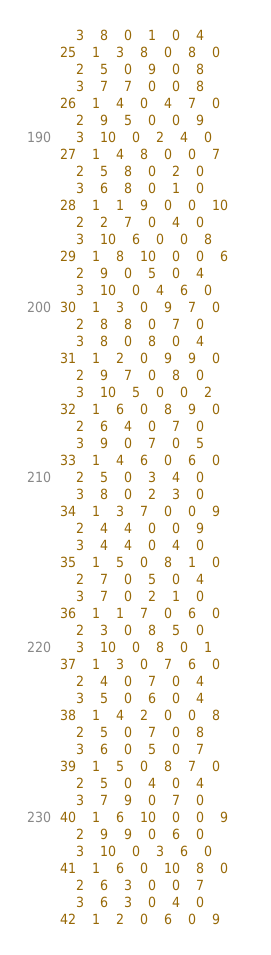Convert code to text. <code><loc_0><loc_0><loc_500><loc_500><_ObjectiveC_>	3	8	0	1	0	4	
25	1	3	8	0	8	0	
	2	5	0	9	0	8	
	3	7	7	0	0	8	
26	1	4	0	4	7	0	
	2	9	5	0	0	9	
	3	10	0	2	4	0	
27	1	4	8	0	0	7	
	2	5	8	0	2	0	
	3	6	8	0	1	0	
28	1	1	9	0	0	10	
	2	2	7	0	4	0	
	3	10	6	0	0	8	
29	1	8	10	0	0	6	
	2	9	0	5	0	4	
	3	10	0	4	6	0	
30	1	3	0	9	7	0	
	2	8	8	0	7	0	
	3	8	0	8	0	4	
31	1	2	0	9	9	0	
	2	9	7	0	8	0	
	3	10	5	0	0	2	
32	1	6	0	8	9	0	
	2	6	4	0	7	0	
	3	9	0	7	0	5	
33	1	4	6	0	6	0	
	2	5	0	3	4	0	
	3	8	0	2	3	0	
34	1	3	7	0	0	9	
	2	4	4	0	0	9	
	3	4	4	0	4	0	
35	1	5	0	8	1	0	
	2	7	0	5	0	4	
	3	7	0	2	1	0	
36	1	1	7	0	6	0	
	2	3	0	8	5	0	
	3	10	0	8	0	1	
37	1	3	0	7	6	0	
	2	4	0	7	0	4	
	3	5	0	6	0	4	
38	1	4	2	0	0	8	
	2	5	0	7	0	8	
	3	6	0	5	0	7	
39	1	5	0	8	7	0	
	2	5	0	4	0	4	
	3	7	9	0	7	0	
40	1	6	10	0	0	9	
	2	9	9	0	6	0	
	3	10	0	3	6	0	
41	1	6	0	10	8	0	
	2	6	3	0	0	7	
	3	6	3	0	4	0	
42	1	2	0	6	0	9	</code> 